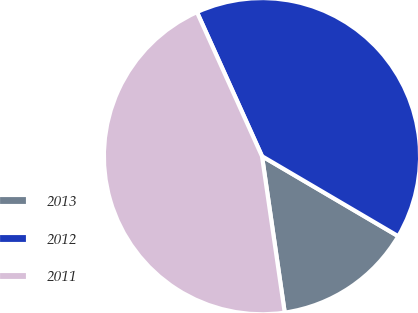Convert chart to OTSL. <chart><loc_0><loc_0><loc_500><loc_500><pie_chart><fcel>2013<fcel>2012<fcel>2011<nl><fcel>14.25%<fcel>40.2%<fcel>45.55%<nl></chart> 